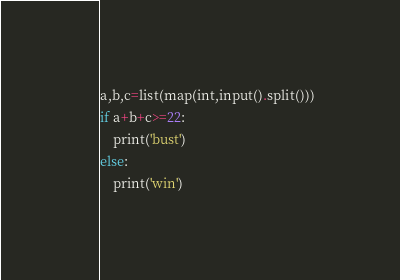Convert code to text. <code><loc_0><loc_0><loc_500><loc_500><_Python_>a,b,c=list(map(int,input().split()))
if a+b+c>=22:
    print('bust')
else:
    print('win')</code> 